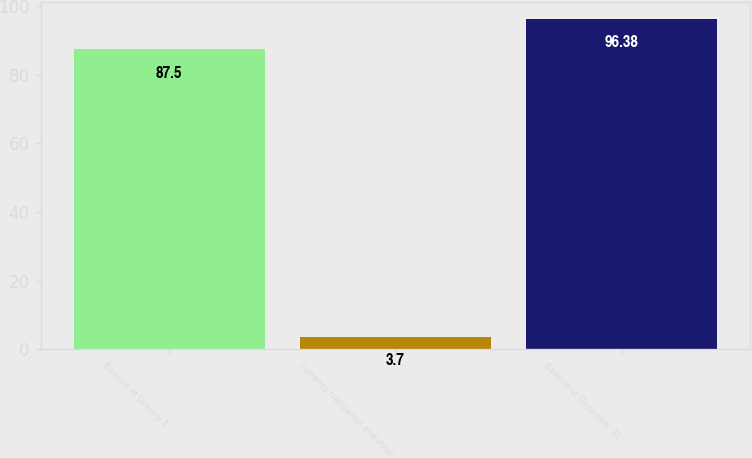Convert chart to OTSL. <chart><loc_0><loc_0><loc_500><loc_500><bar_chart><fcel>Balance at January 1<fcel>Currency translation and other<fcel>Balance at December 31<nl><fcel>87.5<fcel>3.7<fcel>96.38<nl></chart> 